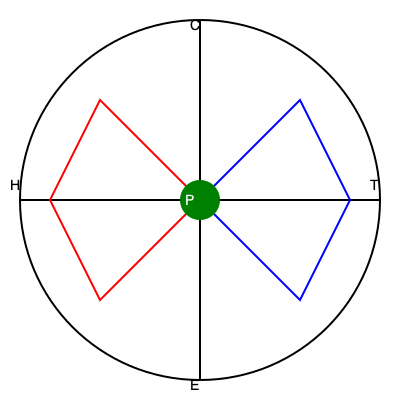In the diagram, symbols represent various cultural and technological influences on society. What pattern emerges when considering the relationship between the central element (P) and the surrounding geometric shapes? 1. The diagram represents a complex array of symbols within a circular boundary, divided into quadrants by two perpendicular lines.

2. The quadrants are labeled with letters: T (top right), C (top left), H (bottom left), and E (bottom right). These may represent Technology, Culture, Humanity, and Environment, respectively.

3. Two geometric shapes are present:
   a. A blue quadrilateral in the T-C quadrants (top half)
   b. A red quadrilateral in the H-E quadrants (bottom half)

4. At the center is a green circle labeled "P", likely representing Philosophy.

5. The pattern that emerges is a balance or tension between the upper and lower halves:
   a. The upper half (T-C) represents the influences of technology and culture, often associated with progress and development.
   b. The lower half (H-E) represents humanity and the environment, often seen as more fundamental or traditional elements.

6. The central "P" (Philosophy) acts as a mediator or pivot point between these opposing forces, suggesting that philosophical inquiry plays a crucial role in balancing and interpreting the influences of technology, culture, humanity, and the environment on society.

7. The symmetry of the shapes implies an interconnectedness of these elements, with philosophy at the core, questioning and examining their relationships.

8. This pattern challenges a purely deterministic view of technological and cultural influence on society by placing equal emphasis on human and environmental factors, with philosophy as the central, mediating force.
Answer: Balanced tension between technological-cultural and human-environmental influences, mediated by philosophy 